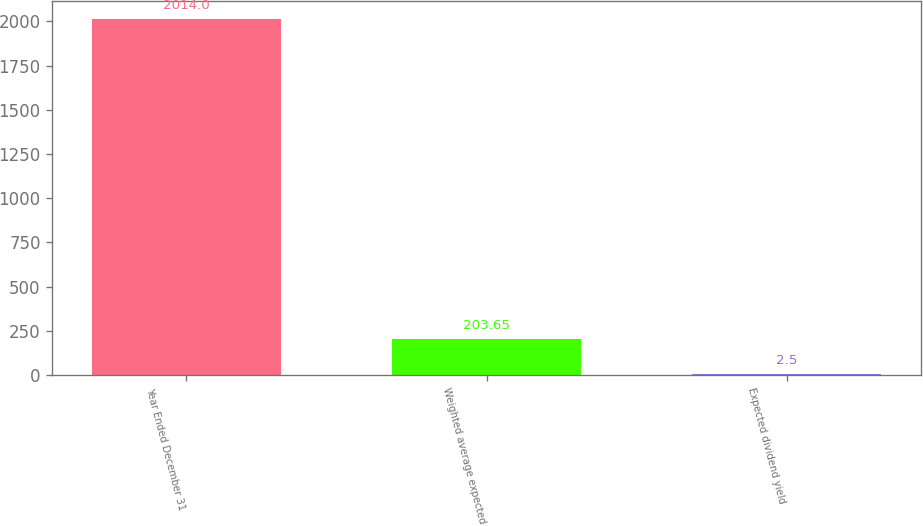<chart> <loc_0><loc_0><loc_500><loc_500><bar_chart><fcel>Year Ended December 31<fcel>Weighted average expected<fcel>Expected dividend yield<nl><fcel>2014<fcel>203.65<fcel>2.5<nl></chart> 